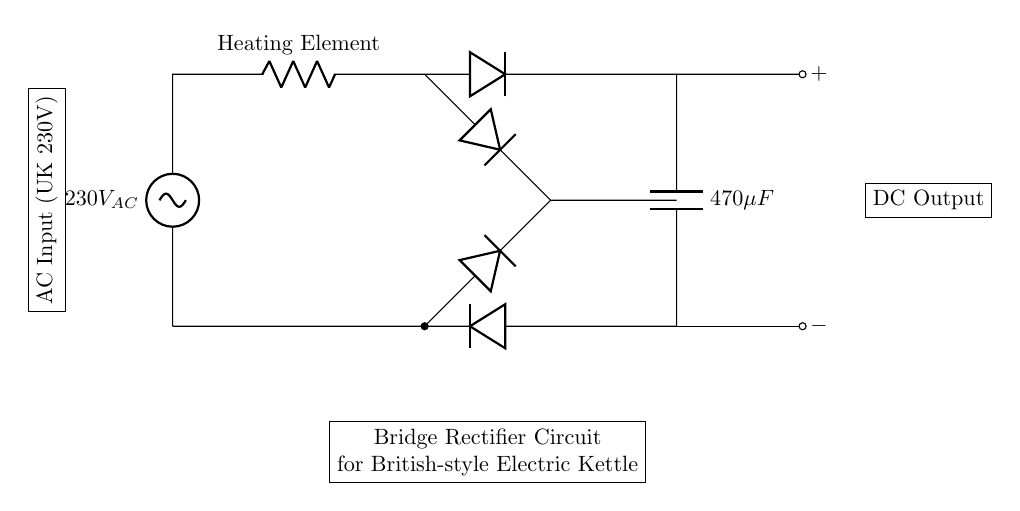What is the AC input voltage for this circuit? The circuit indicates an AC input voltage labeled as 230V AC, which is typical for appliances in the UK.
Answer: 230V AC What is the capacitance value in the circuit? The circuit shows a capacitor labeled with a value of 470 microfarads, which indicates the capacitance used in the rectification process.
Answer: 470 microfarads How many diodes are used in the bridge rectifier? The diagram displays a total of four diodes, which are connected in a specific arrangement to form the bridge rectifier.
Answer: Four What component is directly connected to the DC output? The capacitor is connected to the DC output terminal, smoothing the rectified voltage and providing a more stable DC supply for the heating element.
Answer: Capacitor What is the purpose of the heating element in this circuit? The heating element in this setup is responsible for converting the electrical energy into heat energy, which is essential for the kettle's operation.
Answer: Heating element How is the DC output labeled in the circuit? The DC output has two terminal points labeled as positive and negative, indicating the polarity of the output voltage after rectification.
Answer: Positive and negative 